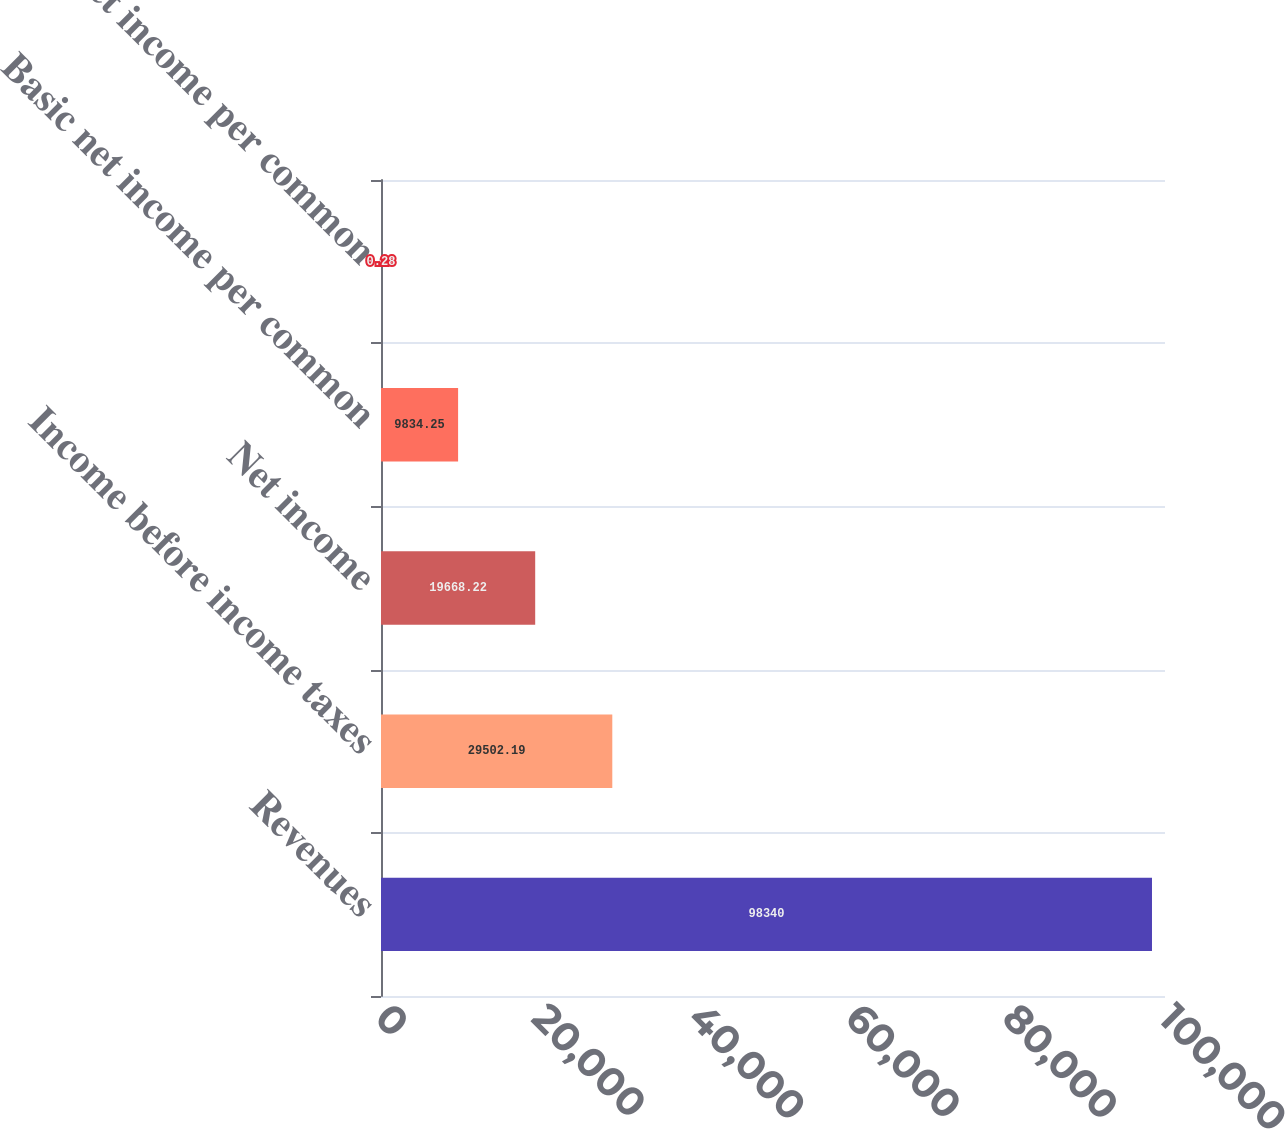Convert chart to OTSL. <chart><loc_0><loc_0><loc_500><loc_500><bar_chart><fcel>Revenues<fcel>Income before income taxes<fcel>Net income<fcel>Basic net income per common<fcel>Diluted net income per common<nl><fcel>98340<fcel>29502.2<fcel>19668.2<fcel>9834.25<fcel>0.28<nl></chart> 